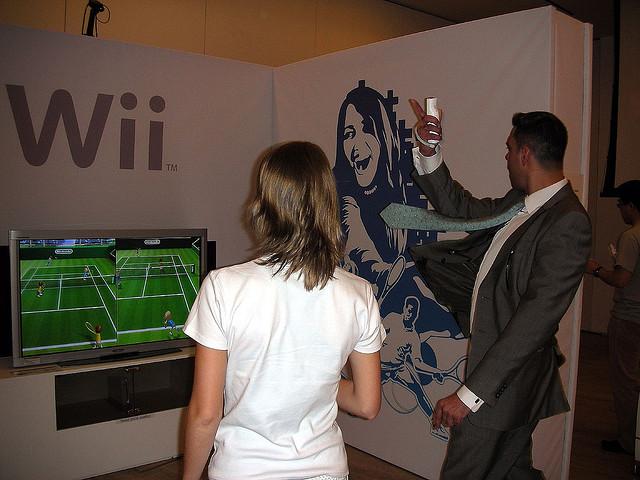Do these boys know each other?
Be succinct. Yes. What is the girl's favorite team?
Short answer required. Unknown. Are these two a couple?
Give a very brief answer. No. What color is the ceiling?
Keep it brief. White. What store is this?
Give a very brief answer. Wii. How many people are watching?
Quick response, please. 2. What is in the man's hand?
Give a very brief answer. Wii controller. Are you able to tell what the man is doing from the photo?
Write a very short answer. Yes. Are both people standing up straight?
Quick response, please. Yes. Is there nurse wearing scrubs?
Keep it brief. No. What color is the girl's shirt?
Give a very brief answer. White. What color is the woman's shirt?
Write a very short answer. White. What are they doing?
Short answer required. Playing wii. Are they watching a tennis match?
Answer briefly. No. 